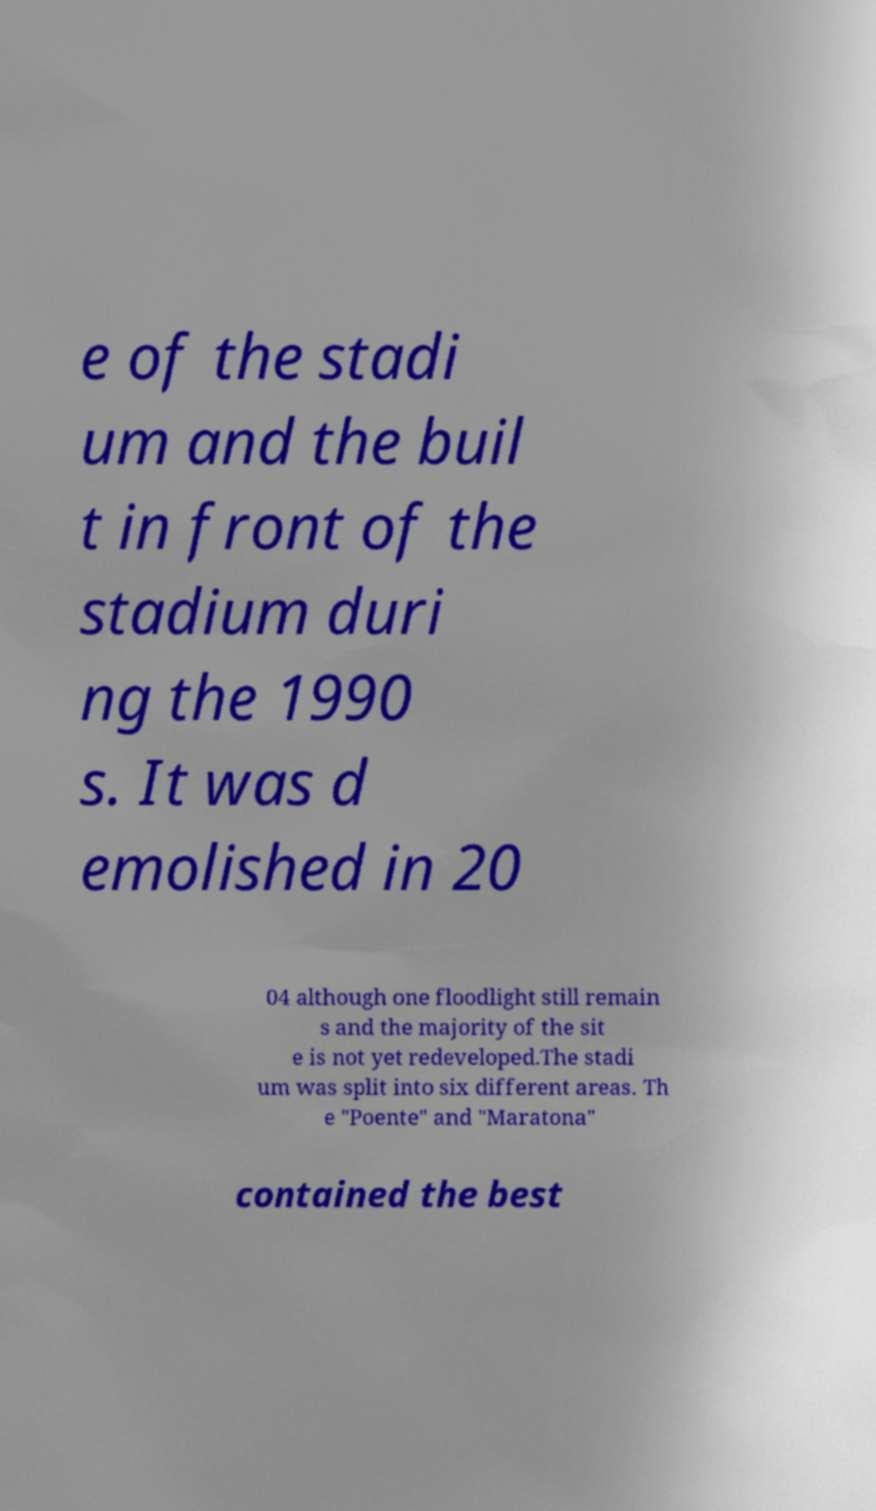Can you accurately transcribe the text from the provided image for me? e of the stadi um and the buil t in front of the stadium duri ng the 1990 s. It was d emolished in 20 04 although one floodlight still remain s and the majority of the sit e is not yet redeveloped.The stadi um was split into six different areas. Th e "Poente" and "Maratona" contained the best 